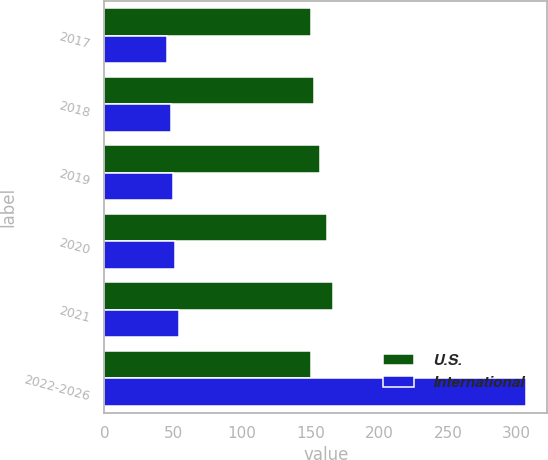Convert chart to OTSL. <chart><loc_0><loc_0><loc_500><loc_500><stacked_bar_chart><ecel><fcel>2017<fcel>2018<fcel>2019<fcel>2020<fcel>2021<fcel>2022-2026<nl><fcel>U.S.<fcel>150.3<fcel>152.7<fcel>157.2<fcel>161.8<fcel>166.7<fcel>150.3<nl><fcel>International<fcel>45.7<fcel>48.3<fcel>50.2<fcel>51.1<fcel>54.3<fcel>306.9<nl></chart> 